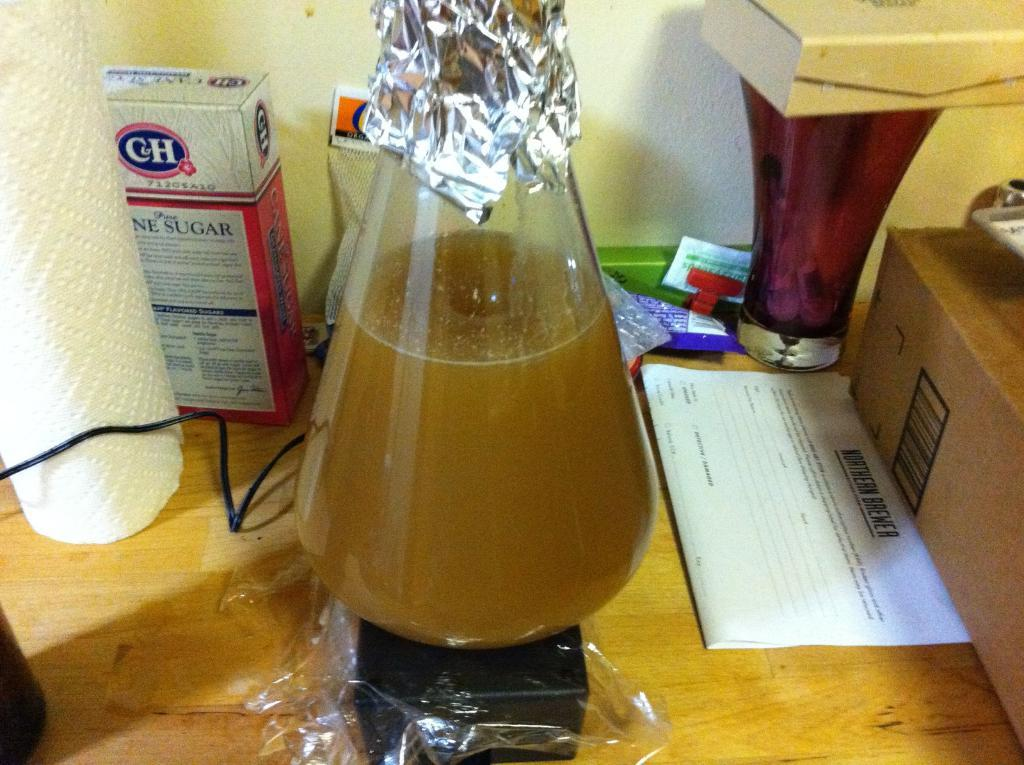<image>
Describe the image concisely. A liquid is in a glass container next to a box of sugar. 